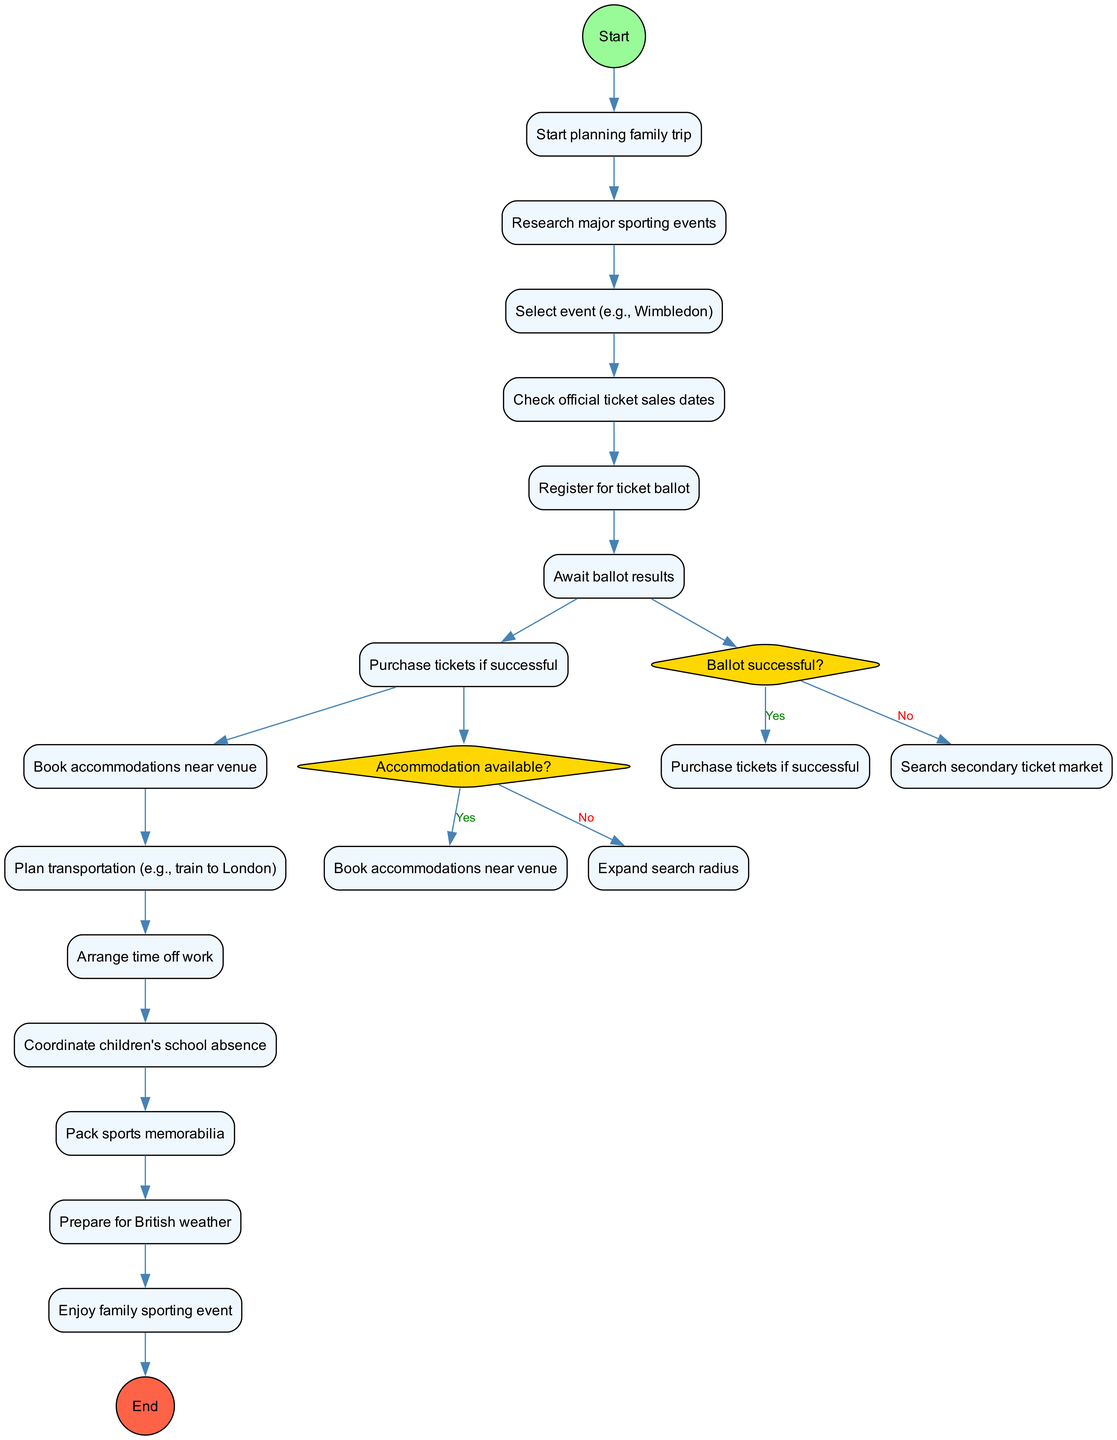What is the first activity in the diagram? The first activity is listed in the activities section of the diagram as "Research major sporting events", which follows the initial node "Start planning family trip".
Answer: Research major sporting events How many activities are there in total? By counting the activities section in the diagram, there are 12 activities listed, including the one after the initial node and before the final node.
Answer: 12 What happens after the decision "Ballot successful?" if the answer is "No"? In the diagram, if the result of "Ballot successful?" is "No", the flow leads to the activity "Search secondary ticket market". This indicates that if the ballot for tickets is unsuccessful, alternate options are explored.
Answer: Search secondary ticket market What is the final node in the diagram? The final node is indicated at the end of the activities and denotes the completion, which is "Enjoy family sporting event". It's the endpoint of the entire process.
Answer: Enjoy family sporting event What activity follows "Arrange time off work"? Looking at the activities flow, the activity that follows "Arrange time off work" is "Coordinate children's school absence". This indicates that once time off is arranged, attention turns to managing the children's school schedules.
Answer: Coordinate children's school absence What happens if "Accommodation available?" is answered "No"? If "Accommodation available?" is answered "No", the diagram directs to "Expand search radius", meaning if suitable accommodations aren't found, the search area will be broadened to find options.
Answer: Expand search radius How many decision points are in the diagram? There are two decision points represented by diamonds in the diagram: "Ballot successful?" and "Accommodation available?". Each serves as a point to assess conditions before progressing.
Answer: 2 What is the activity before "Book accommodations near venue"? The activity that immediately precedes "Book accommodations near venue" is "Check official ticket sales dates". This is key in timing decisions related to accommodations.
Answer: Check official ticket sales dates 